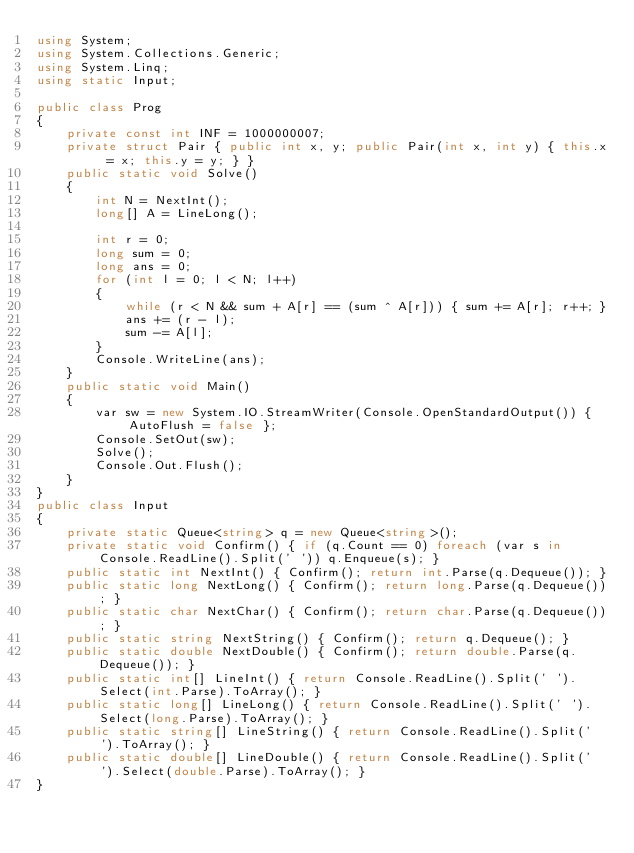<code> <loc_0><loc_0><loc_500><loc_500><_C#_>using System;
using System.Collections.Generic;
using System.Linq;
using static Input;

public class Prog
{
    private const int INF = 1000000007;
    private struct Pair { public int x, y; public Pair(int x, int y) { this.x = x; this.y = y; } }
    public static void Solve()
    {
        int N = NextInt();
        long[] A = LineLong();

        int r = 0;
        long sum = 0;
        long ans = 0;
        for (int l = 0; l < N; l++)
        {
            while (r < N && sum + A[r] == (sum ^ A[r])) { sum += A[r]; r++; }
            ans += (r - l);
            sum -= A[l];
        }
        Console.WriteLine(ans);
    }
    public static void Main()
    {
        var sw = new System.IO.StreamWriter(Console.OpenStandardOutput()) { AutoFlush = false };
        Console.SetOut(sw);
        Solve();
        Console.Out.Flush();
    }
}
public class Input
{
    private static Queue<string> q = new Queue<string>();
    private static void Confirm() { if (q.Count == 0) foreach (var s in Console.ReadLine().Split(' ')) q.Enqueue(s); }
    public static int NextInt() { Confirm(); return int.Parse(q.Dequeue()); }
    public static long NextLong() { Confirm(); return long.Parse(q.Dequeue()); }
    public static char NextChar() { Confirm(); return char.Parse(q.Dequeue()); }
    public static string NextString() { Confirm(); return q.Dequeue(); }
    public static double NextDouble() { Confirm(); return double.Parse(q.Dequeue()); }
    public static int[] LineInt() { return Console.ReadLine().Split(' ').Select(int.Parse).ToArray(); }
    public static long[] LineLong() { return Console.ReadLine().Split(' ').Select(long.Parse).ToArray(); }
    public static string[] LineString() { return Console.ReadLine().Split(' ').ToArray(); }
    public static double[] LineDouble() { return Console.ReadLine().Split(' ').Select(double.Parse).ToArray(); }
}</code> 